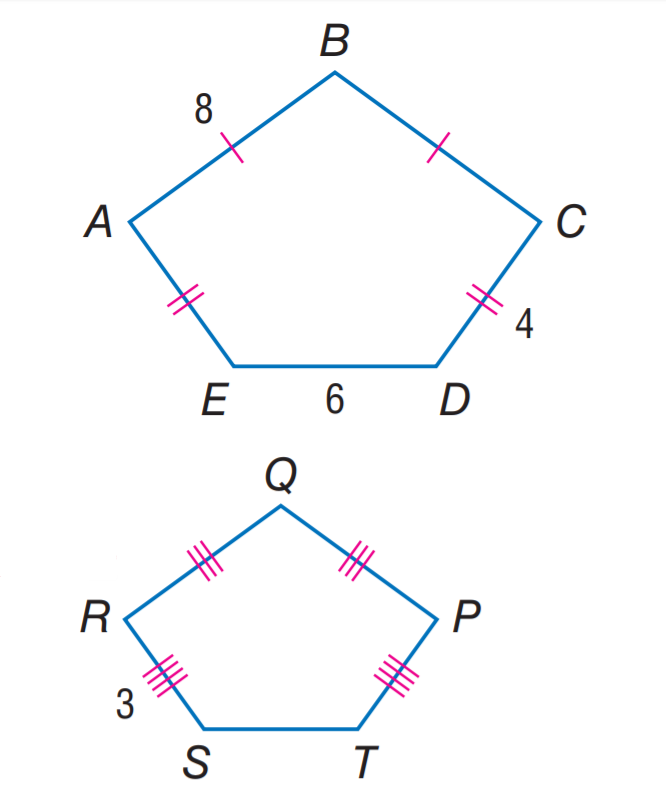Answer the mathemtical geometry problem and directly provide the correct option letter.
Question: If A B C D E \sim P Q R S T, find the scale factor of A B C D E to P Q R S T.
Choices: A: \frac { 4 } { 3 } B: 2 C: \frac { 8 } { 3 } D: 4 A 